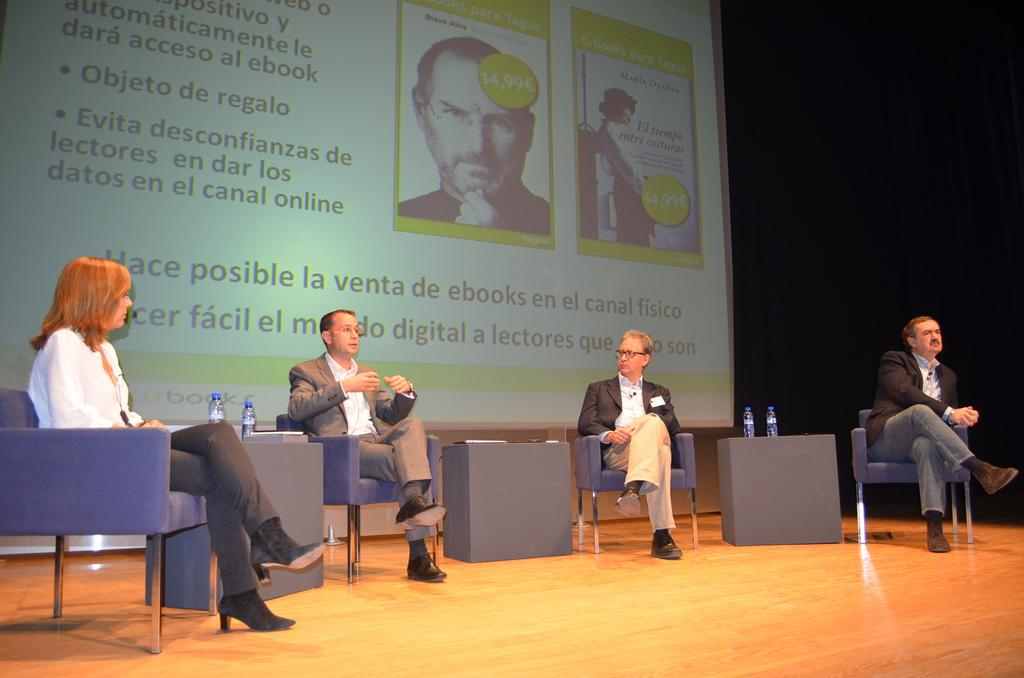What is hanging or displayed in the image? There is a banner in the image. What are the people in the image doing? The people in the image are sitting on chairs. What else can be seen in the image besides the banner and people? There are bottles in the image. Can you see a cat reading a book in the image? No, there is no cat or book present in the image. Is anyone taking a bite out of a bottle in the image? No, there is no one biting anything in the image. 